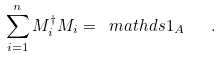Convert formula to latex. <formula><loc_0><loc_0><loc_500><loc_500>\sum _ { i = 1 } ^ { n } M _ { i } ^ { \dagger } M _ { i } = \ m a t h d s { 1 } _ { A } \quad .</formula> 